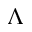Convert formula to latex. <formula><loc_0><loc_0><loc_500><loc_500>\Lambda</formula> 